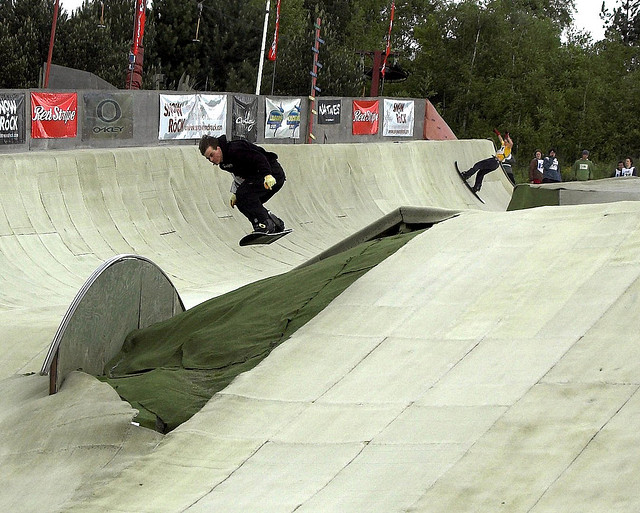Identify and read out the text in this image. RED STOPE O-KEY ROCK Rock NOW 